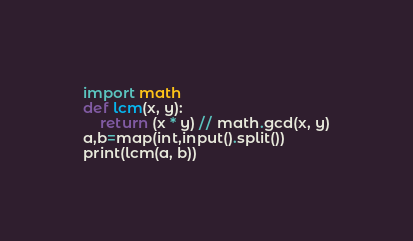<code> <loc_0><loc_0><loc_500><loc_500><_Python_>import math
def lcm(x, y):
    return (x * y) // math.gcd(x, y)
a,b=map(int,input().split())
print(lcm(a, b))</code> 